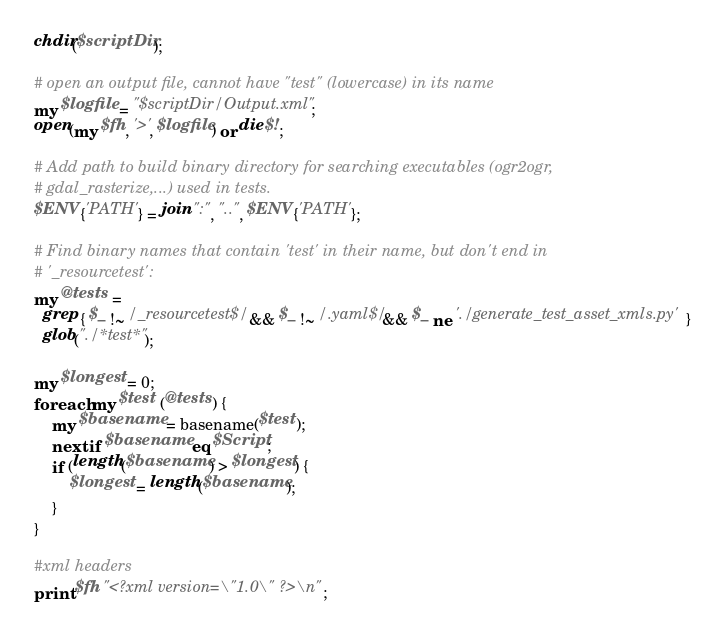Convert code to text. <code><loc_0><loc_0><loc_500><loc_500><_Perl_>chdir($scriptDir);

# open an output file, cannot have "test" (lowercase) in its name
my $logfile = "$scriptDir/Output.xml";
open(my $fh, '>', $logfile) or die $!;

# Add path to build binary directory for searching executables (ogr2ogr,
# gdal_rasterize,...) used in tests.
$ENV{'PATH'} = join ":", "..", $ENV{'PATH'};

# Find binary names that contain 'test' in their name, but don't end in
# '_resourcetest':
my @tests =
  grep { $_ !~ /_resourcetest$/ && $_ !~ /.yaml$/ && $_ ne './generate_test_asset_xmls.py' }
  glob("./*test*");

my $longest = 0;
foreach my $test (@tests) {
    my $basename = basename($test);
    next if $basename eq $Script;
    if (length($basename) > $longest) {
        $longest = length($basename);
    }
}

#xml headers
print $fh "<?xml version=\"1.0\" ?>\n";</code> 